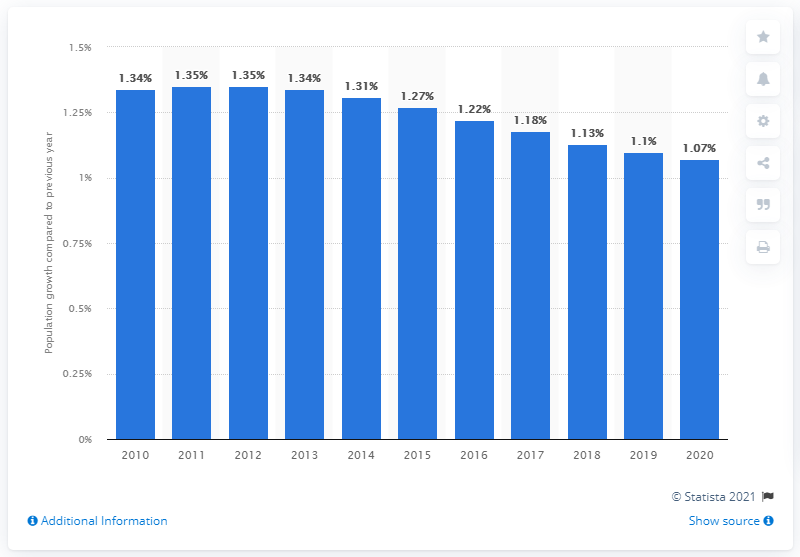Highlight a few significant elements in this photo. According to the data, Indonesia's population grew by 1.07% in 2020. 